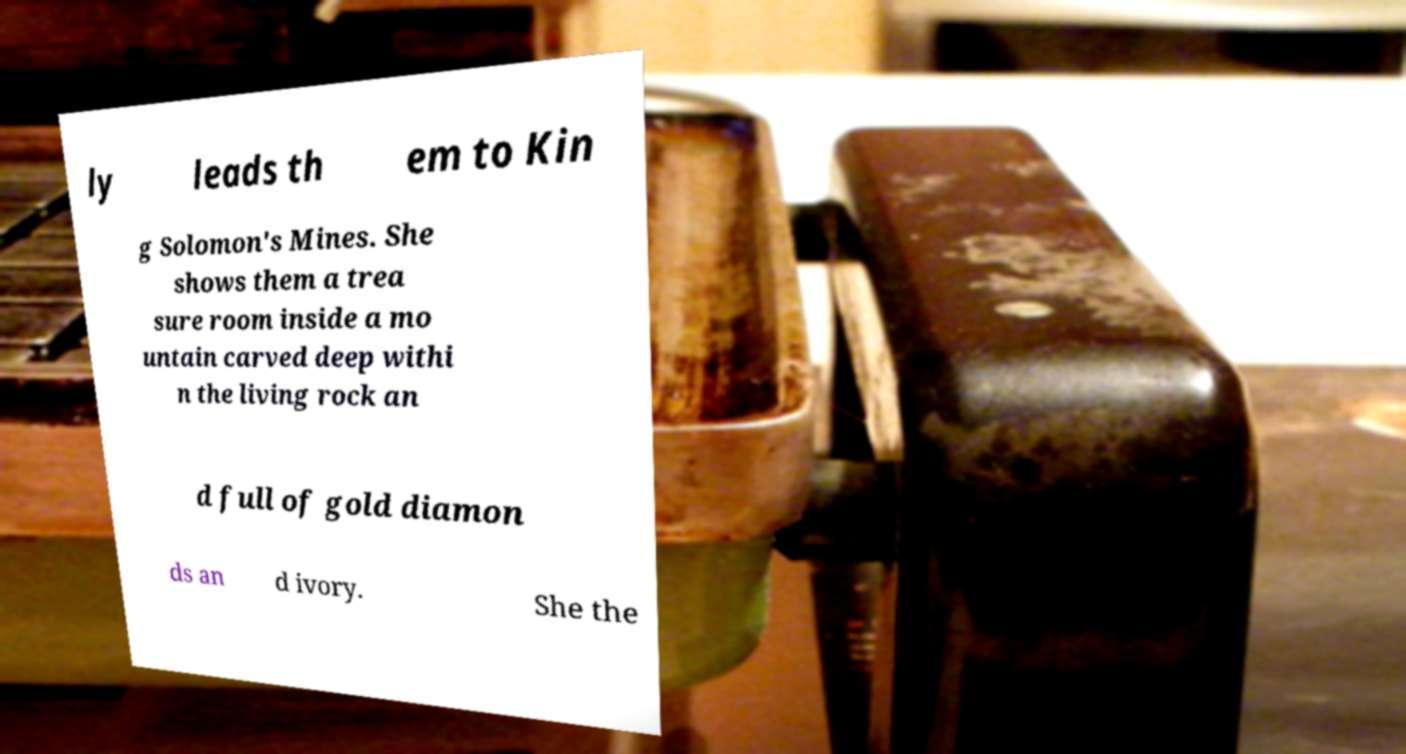For documentation purposes, I need the text within this image transcribed. Could you provide that? ly leads th em to Kin g Solomon's Mines. She shows them a trea sure room inside a mo untain carved deep withi n the living rock an d full of gold diamon ds an d ivory. She the 